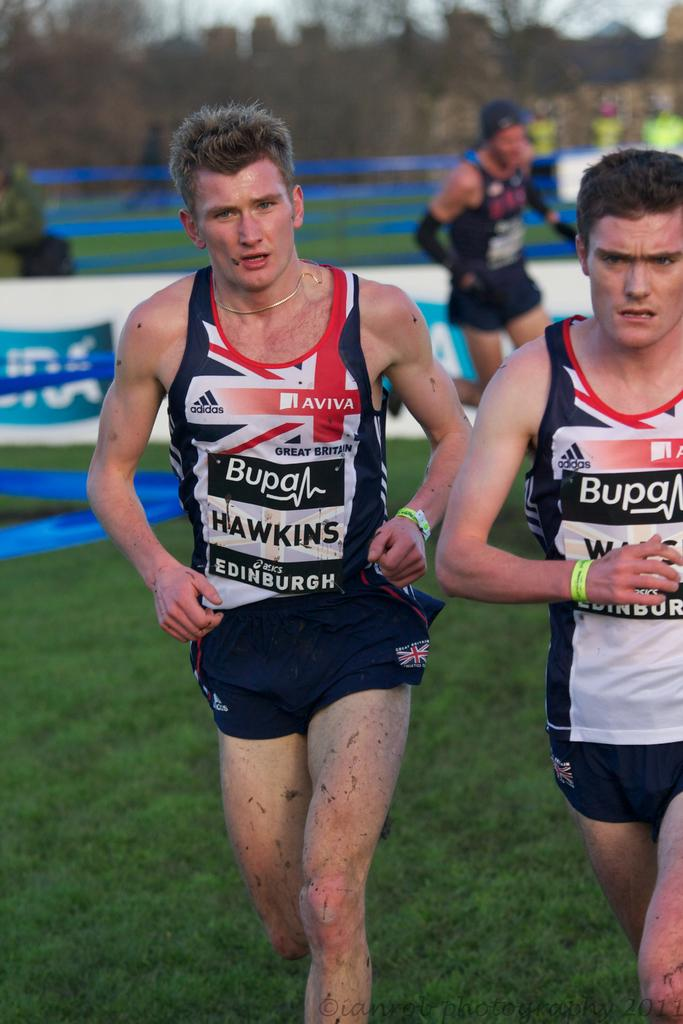Provide a one-sentence caption for the provided image. Runners wear tank tops that were made by adidas. 